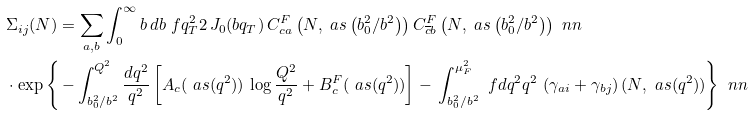<formula> <loc_0><loc_0><loc_500><loc_500>& \Sigma _ { i j } ( N ) = \sum _ { a , b } \int _ { 0 } ^ { \infty } b \, d b \ f { q _ { T } ^ { 2 } } { 2 } \, J _ { 0 } ( b q _ { T } ) \, { C } ^ { F } _ { c a } \left ( N , \ a s \left ( { b _ { 0 } ^ { 2 } } / { b ^ { 2 } } \right ) \right ) { C } ^ { F } _ { \overline { c } b } \left ( N , \ a s \left ( { b _ { 0 } ^ { 2 } } / { b ^ { 2 } } \right ) \right ) \ n n \\ & \cdot \exp \left \{ \, - \int _ { b _ { 0 } ^ { 2 } / b ^ { 2 } } ^ { Q ^ { 2 } } \frac { d q ^ { 2 } } { q ^ { 2 } } \left [ { A } _ { c } ( \ a s ( q ^ { 2 } ) ) \, \log \frac { Q ^ { 2 } } { q ^ { 2 } } + { B } _ { c } ^ { F } ( \ a s ( q ^ { 2 } ) ) \right ] - \, \int _ { { b _ { 0 } ^ { 2 } } / { b ^ { 2 } } } ^ { \mu ^ { 2 } _ { F } } \ f { d q ^ { 2 } } { q ^ { 2 } } \, \left ( \gamma _ { a i } + \gamma _ { b j } \right ) ( N , \ a s ( q ^ { 2 } ) ) \right \} \ n n \\</formula> 